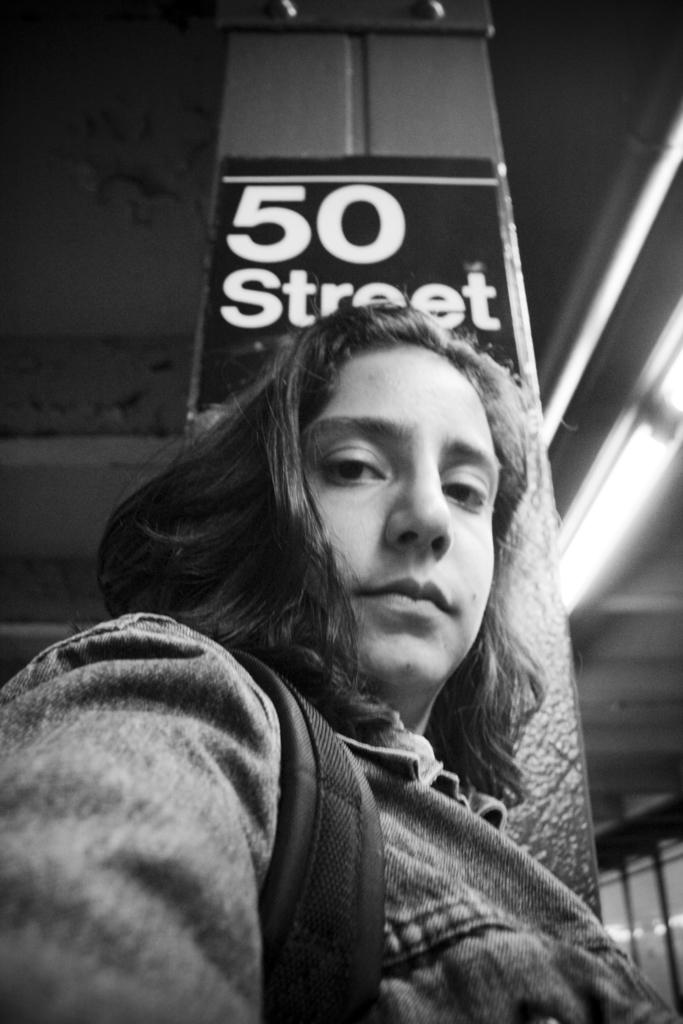Who or what is in the foreground of the image? There is a person in the foreground of the image. What can be seen in the background of the image? There is a board, a pillar, and lights on a rooftop in the background of the image. Can you describe the setting of the image? The image may have been taken in a hall. How many lizards are sitting on the judge's shoulder in the image? There are no lizards or judges present in the image. What type of visitor can be seen in the image? There is no visitor present in the image; only a person in the foreground and various elements in the background are visible. 